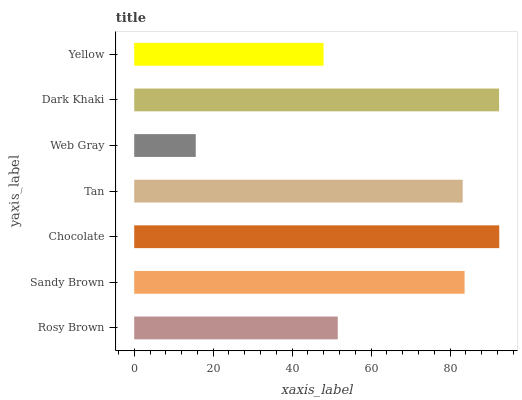Is Web Gray the minimum?
Answer yes or no. Yes. Is Chocolate the maximum?
Answer yes or no. Yes. Is Sandy Brown the minimum?
Answer yes or no. No. Is Sandy Brown the maximum?
Answer yes or no. No. Is Sandy Brown greater than Rosy Brown?
Answer yes or no. Yes. Is Rosy Brown less than Sandy Brown?
Answer yes or no. Yes. Is Rosy Brown greater than Sandy Brown?
Answer yes or no. No. Is Sandy Brown less than Rosy Brown?
Answer yes or no. No. Is Tan the high median?
Answer yes or no. Yes. Is Tan the low median?
Answer yes or no. Yes. Is Rosy Brown the high median?
Answer yes or no. No. Is Sandy Brown the low median?
Answer yes or no. No. 